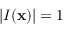<formula> <loc_0><loc_0><loc_500><loc_500>| I ( x ) | = 1</formula> 